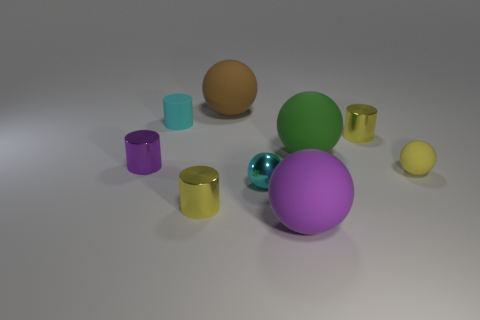There is a purple object in front of the small yellow rubber sphere in front of the small purple metallic cylinder; are there any cyan cylinders behind it? I apologize for the earlier inaccurate answer; upon reviewing the image, there are no cyan cylinders situated behind the small purple metallic cylinder. The objects present are predominantly spheres and cylinders of various colors, but a cyan cylinder is not among them. 